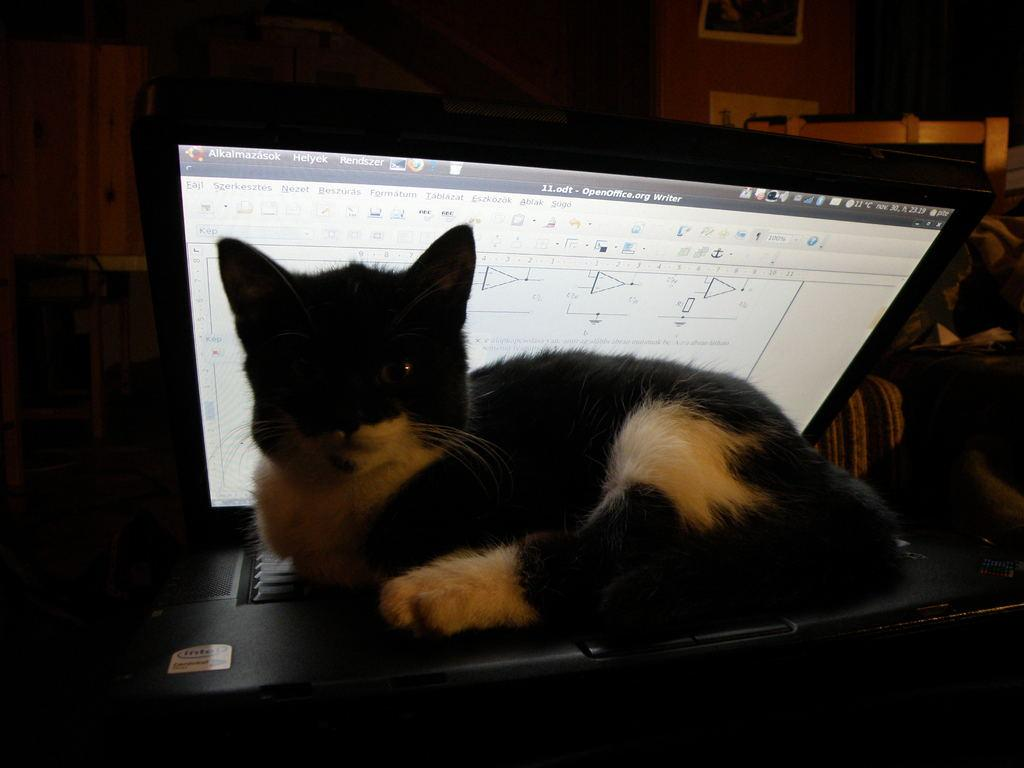What type of animal is in the image? There is a cat in the image. What is the cat sitting on? The cat is sitting on a laptop. Can you describe the background of the image? The background of the image is dark. What type of pleasure can be seen in the image? There is no indication of pleasure in the image; it simply shows a cat sitting on a laptop with a dark background. Can you tell me how many goldfish are swimming in the image? There are no goldfish present in the image. 